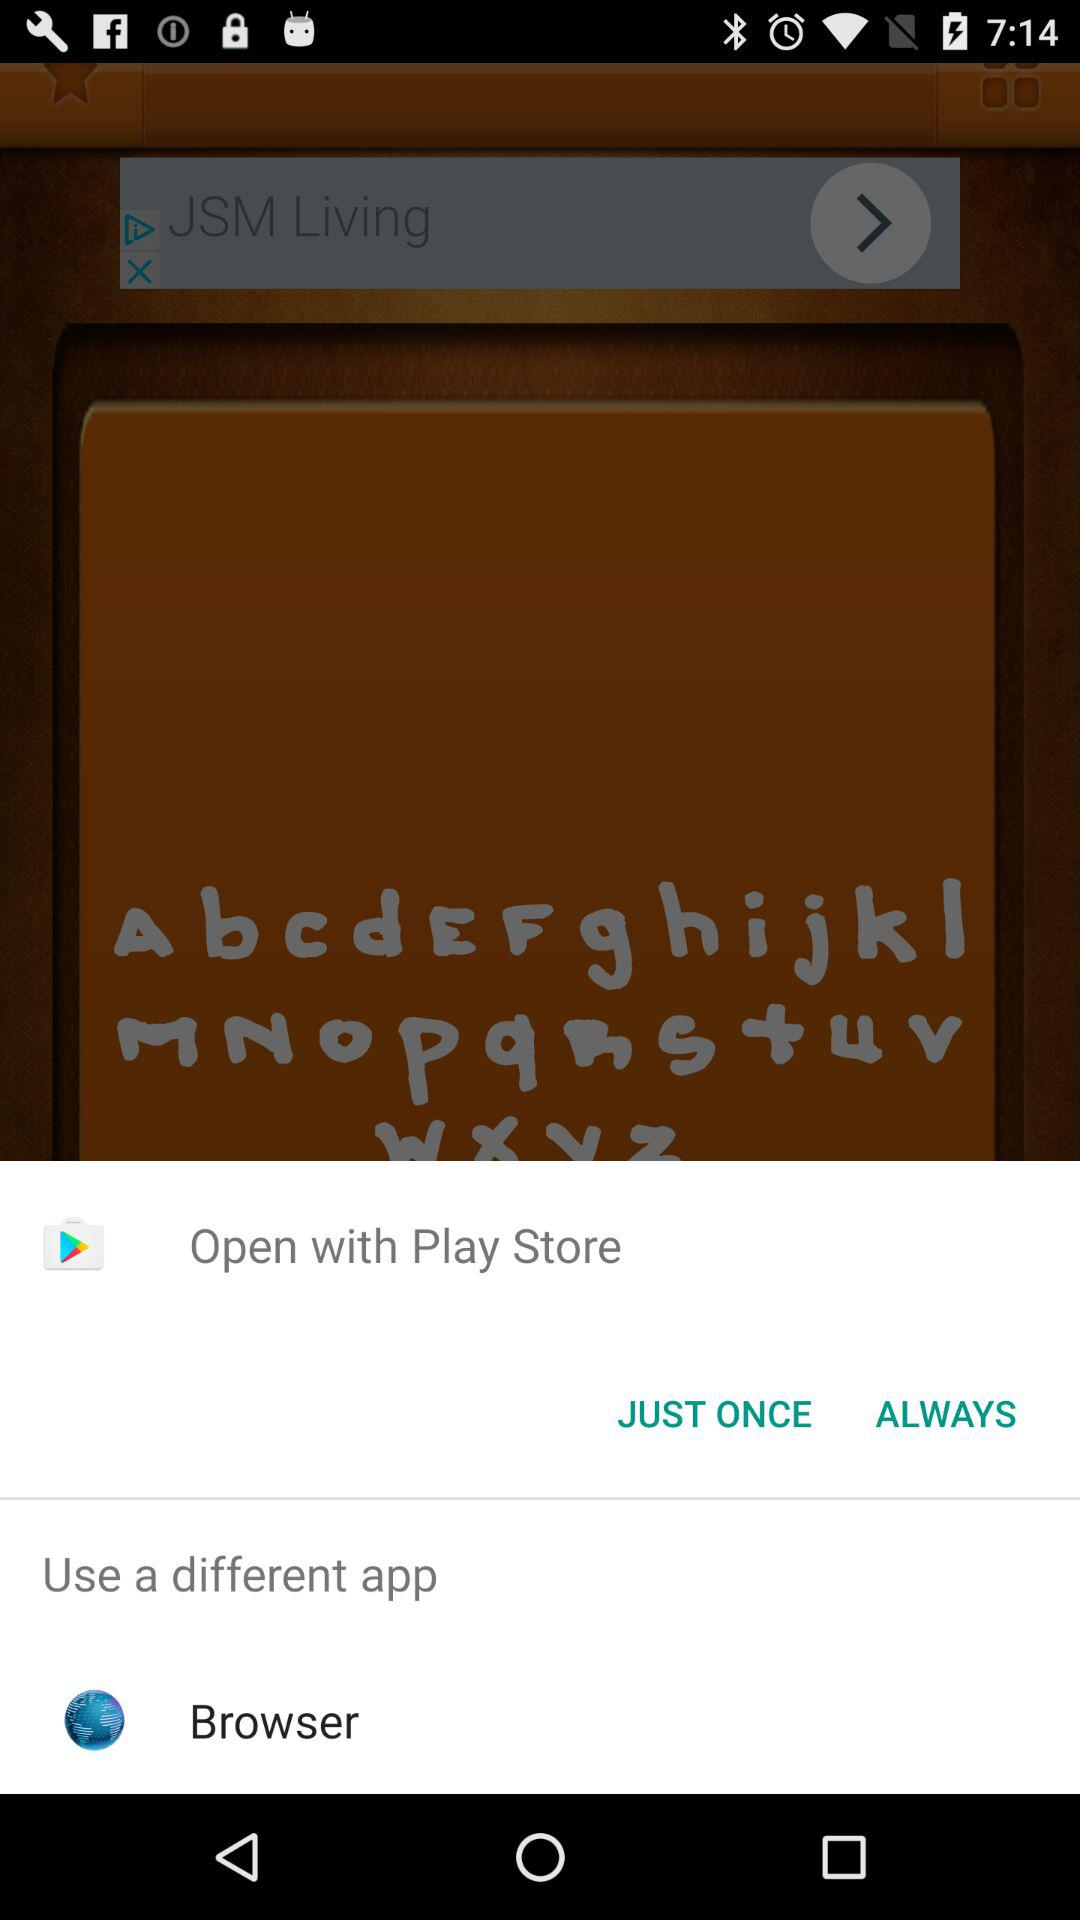What is the name of the application?
When the provided information is insufficient, respond with <no answer>. <no answer> 